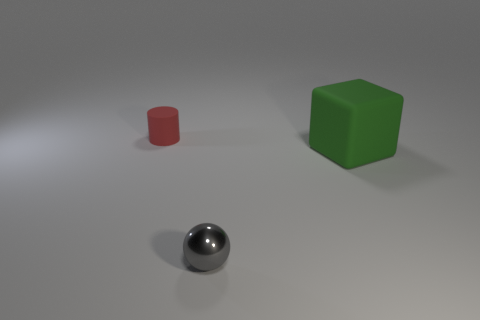Subtract all balls. How many objects are left? 2 Add 3 gray things. How many objects exist? 6 Subtract 1 cylinders. How many cylinders are left? 0 Add 2 cylinders. How many cylinders are left? 3 Add 1 blocks. How many blocks exist? 2 Subtract 0 blue balls. How many objects are left? 3 Subtract all cyan cylinders. Subtract all yellow balls. How many cylinders are left? 1 Subtract all cyan blocks. How many yellow cylinders are left? 0 Subtract all tiny gray metal spheres. Subtract all small gray things. How many objects are left? 1 